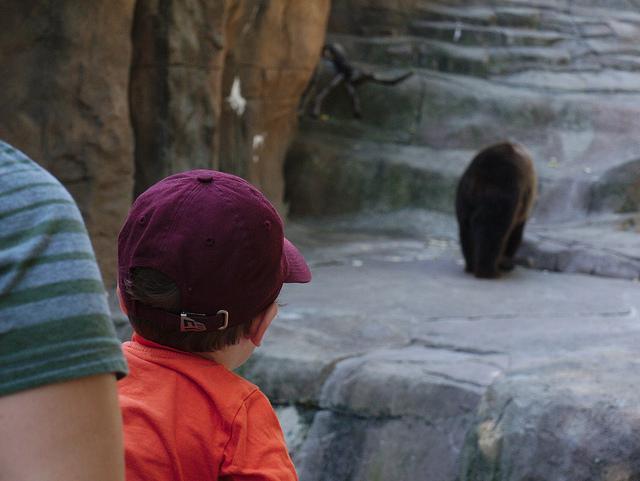How many mammals are in this scene?
Give a very brief answer. 3. How many people are there?
Give a very brief answer. 2. 